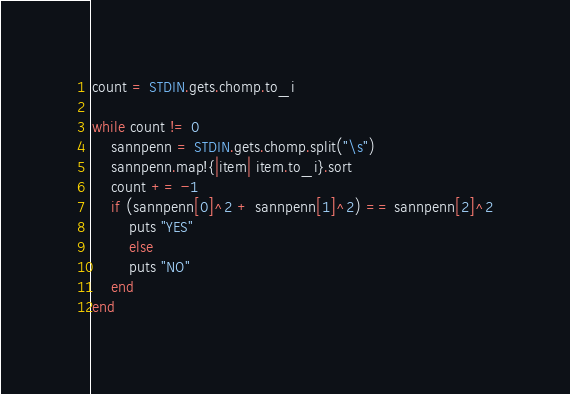Convert code to text. <code><loc_0><loc_0><loc_500><loc_500><_Ruby_>count = STDIN.gets.chomp.to_i

while count != 0
	sannpenn = STDIN.gets.chomp.split("\s")
	sannpenn.map!{|item| item.to_i}.sort
	count += -1
	if (sannpenn[0]^2 + sannpenn[1]^2) == sannpenn[2]^2
		puts "YES"
		else
		puts "NO"
	end
end</code> 